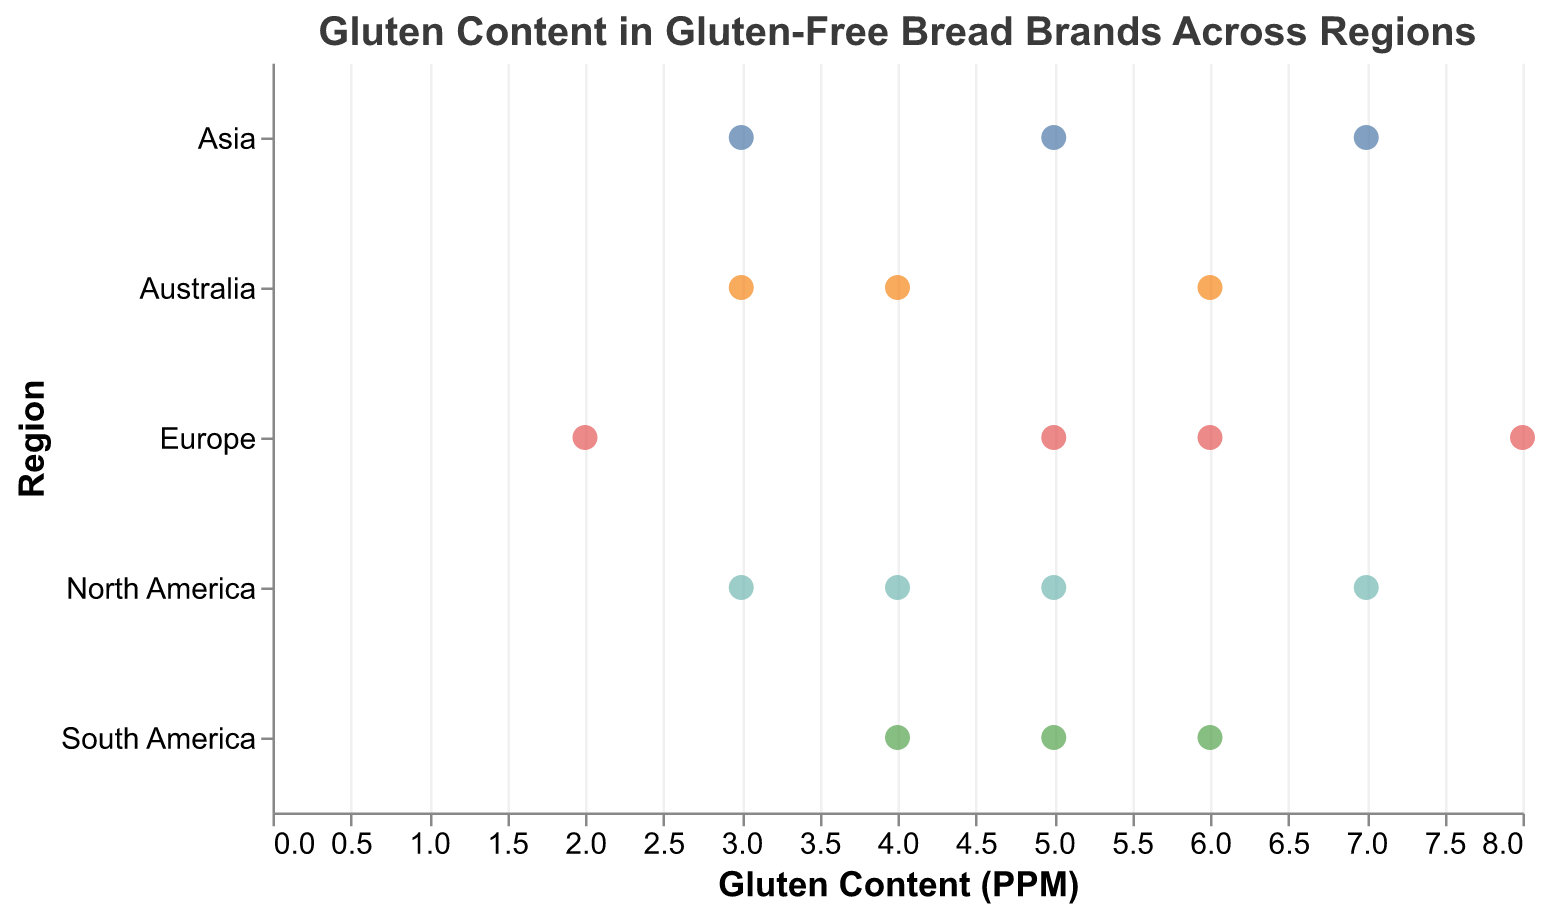What's the title of the figure? The title of the figure is located at the top and provides a basic description of the data shown in the plot.
Answer: Gluten Content in Gluten-Free Bread Brands Across Regions How many data points are shown for Europe? To answer this, count the individual points plotted in the "Europe" region on the y-axis. There are four data points: Genius, Warburtons, Bfree, and Schar.
Answer: 4 Which brand has the highest gluten content in North America? Look for the highest point plotted in the "North America" region. Schar has the highest gluten content at 7 PPM.
Answer: Schar Between which regions is the average gluten content the highest, North America or Asia? Calculate the average gluten content for each region. For North America, (5 + 3 + 7 + 4) / 4 = 4.75 PPM. For Asia, (7 + 5 + 3) / 3 = 5 PPM. Asia has the higher average gluten content.
Answer: Asia Which brand has the lowest gluten content, and from which region? Identify the brand with the smallest value on the x-axis in any region. Warburtons in Europe has the lowest gluten content of 2 PPM.
Answer: Warburtons from Europe Is there a region with completely similar gluten content levels among its represented brands? Evaluate each region to see if any have brands with identical gluten content values. None of the regions have completely similar levels; all brands have different values.
Answer: No What's the gluten content range of brands in Australia? Identify the minimum and maximum gluten content values within the Australia region. The minimum is 3 PPM (Abbott's Village Bakery), and the maximum is 6 PPM (Country Life). Therefore, the range is 6 - 3 = 3 PPM.
Answer: 3 PPM Compare the gluten content of the Schar brand in different regions. Locate the Schar brand points in both North America and Europe. North America has 7 PPM, and Europe has 8 PPM. The gluten content is higher in Europe.
Answer: Higher in Europe What is the commonality between the brands Bfree and Orgran? Bfree and Orgran have the same gluten content level of 5 PPM, even though they are from different regions (Europe and Asia, respectively).
Answer: Both have 5 PPM How does the gluten content of Helga's in Australia compare to that of Genius in Europe? Helga's has a gluten content of 4 PPM and Genius has 6 PPM. Helga's has less gluten content than Genius.
Answer: Helga's has less gluten content 